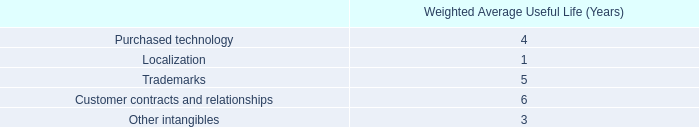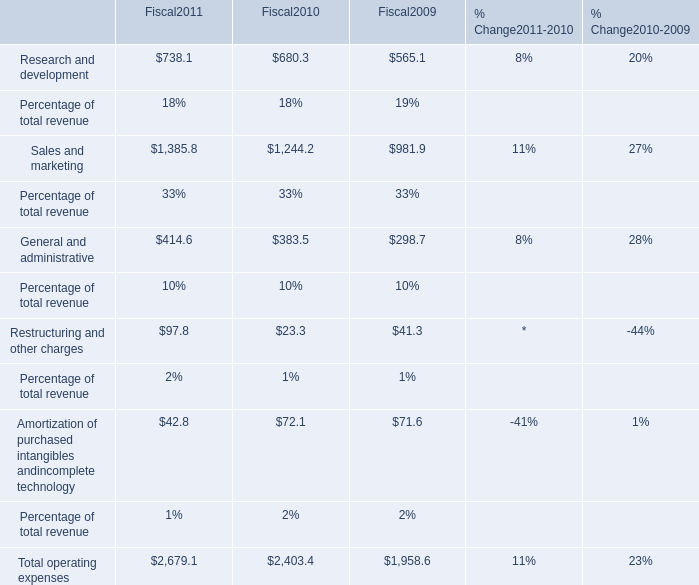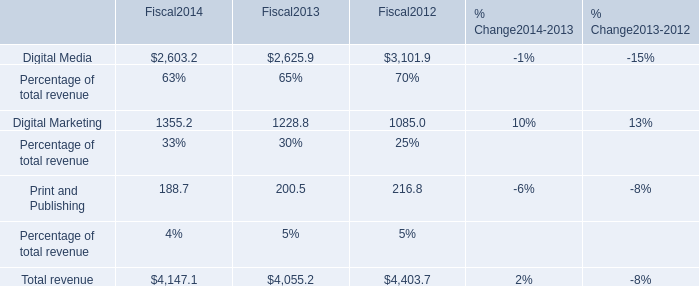What's the sum of Research and development in 2011? 
Answer: 738.1. 